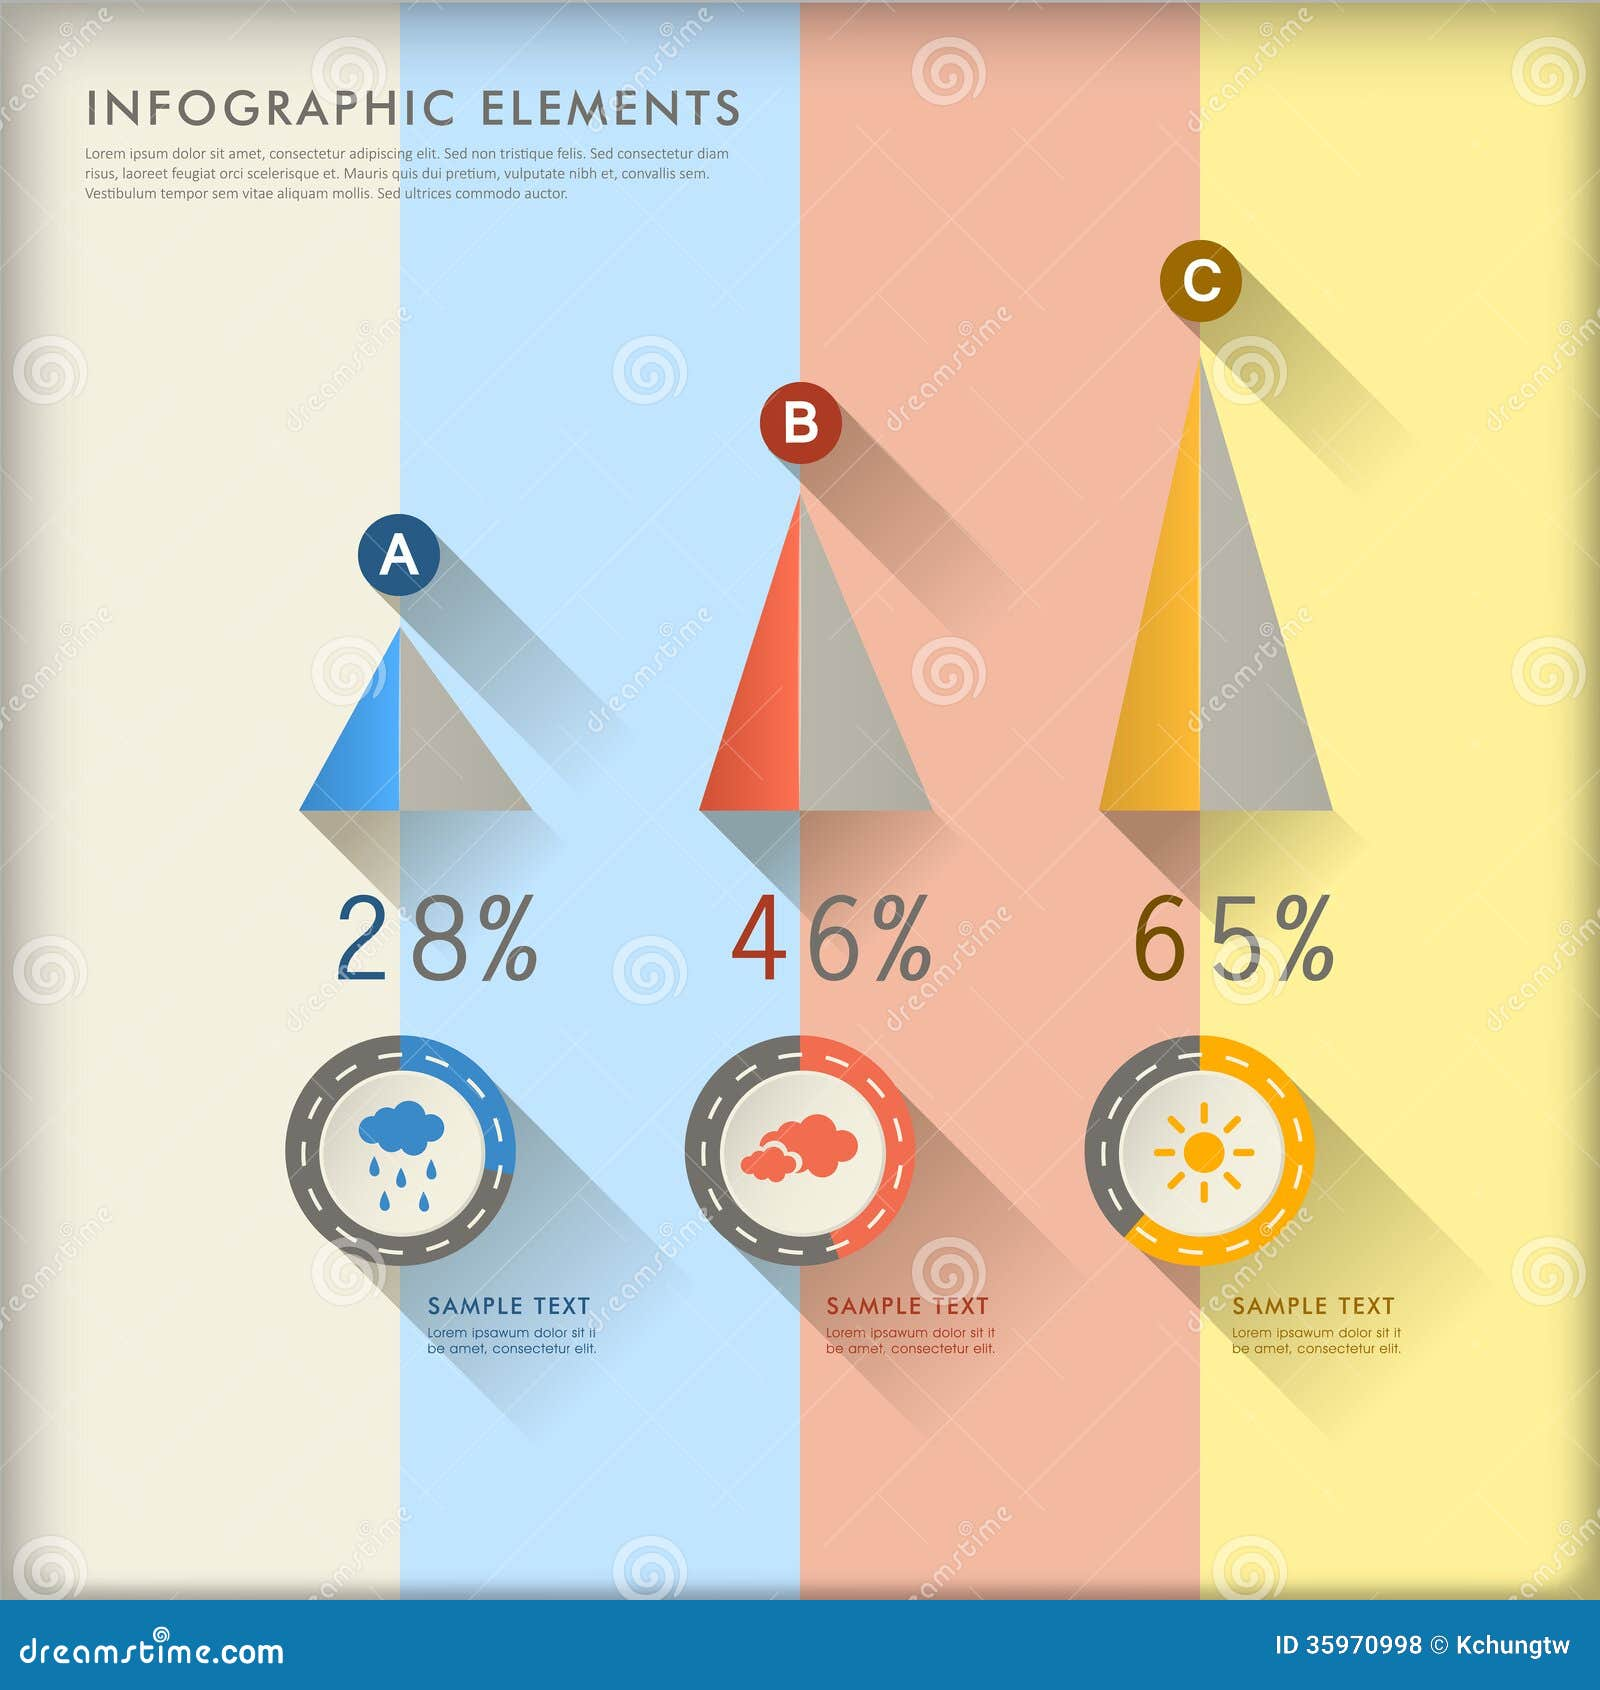How might this infographic be used to guide decisions in planning future events or activities? This infographic can be a valuable tool for event planners and organizers. By displaying the relative popularity of different categories, be it weather conditions, emotions, or activities, planners can make informed decisions about where to focus their resources and efforts. For instance, if the infographic represents favorite camp activities, organizers might choose to allocate more resources towards outdoor play and adventure activities given their high popularity. Conversely, recognizing a lower percentage for indoor activities might lead to innovative ways to make them more engaging or to minimize their focus. The visual clarity and straightforward representation of data facilitate quick insights, thus enabling efficient and effective planning. 